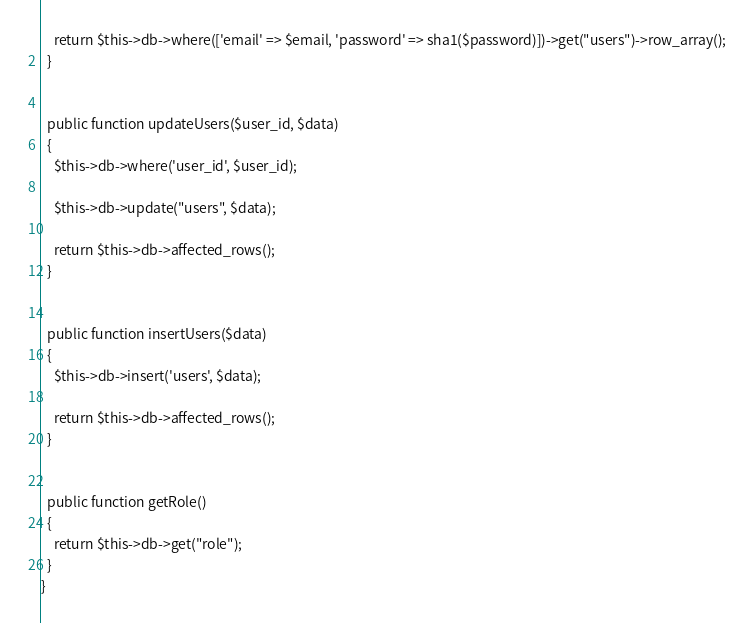Convert code to text. <code><loc_0><loc_0><loc_500><loc_500><_PHP_>    return $this->db->where(['email' => $email, 'password' => sha1($password)])->get("users")->row_array();
  }


  public function updateUsers($user_id, $data)
  {
    $this->db->where('user_id', $user_id);

    $this->db->update("users", $data);

    return $this->db->affected_rows();
  }


  public function insertUsers($data)
  {
    $this->db->insert('users', $data);

    return $this->db->affected_rows();
  }


  public function getRole()
  {
    return $this->db->get("role");
  }
}
</code> 